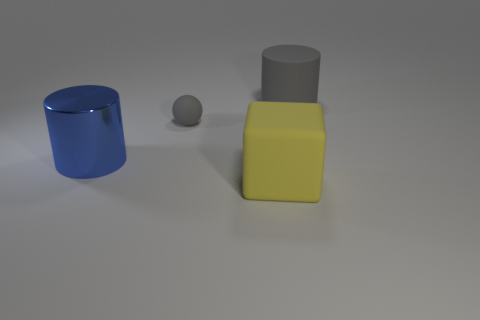Add 3 tiny cyan matte spheres. How many objects exist? 7 Subtract all blocks. How many objects are left? 3 Subtract all big red rubber blocks. Subtract all gray spheres. How many objects are left? 3 Add 2 yellow things. How many yellow things are left? 3 Add 3 blue metal cylinders. How many blue metal cylinders exist? 4 Subtract 0 yellow cylinders. How many objects are left? 4 